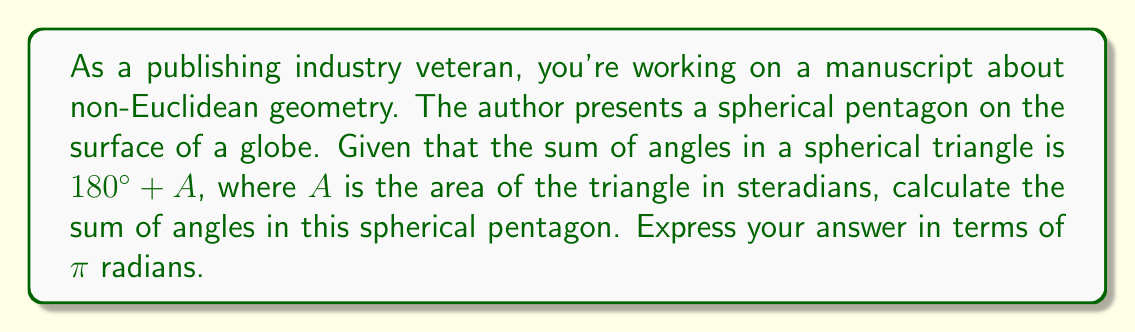Help me with this question. Let's approach this step-by-step:

1) First, recall that any spherical polygon can be divided into $(n-2)$ spherical triangles, where $n$ is the number of sides. For a pentagon, $n=5$, so we can divide it into 3 spherical triangles.

2) The sum of angles in a spherical triangle is given by:
   $$S_{triangle} = \pi + A$$
   where $A$ is the area of the triangle in steradians.

3) For our pentagon, the sum of angles will be the sum of the angles in these 3 triangles:
   $$S_{pentagon} = 3(\pi + A_1 + A_2 + A_3)$$
   where $A_1$, $A_2$, and $A_3$ are the areas of the three triangles.

4) The sum $A_1 + A_2 + A_3$ is simply the area of the entire pentagon. Let's call this $A_{pentagon}$.

5) Therefore, we can write:
   $$S_{pentagon} = 3\pi + A_{pentagon}$$

6) Now, we need to consider the area of a sphere. The total area of a sphere is $4\pi$ steradians.

7) A pentagon can cover at most half of a sphere's surface (if it were larger, it would no longer be a pentagon but would wrap around to form a different shape).

8) Therefore, $0 < A_{pentagon} \leq 2\pi$

9) Substituting this back into our equation:
   $$3\pi < S_{pentagon} \leq 5\pi$$

10) Thus, the sum of angles in a spherical pentagon is always greater than $3\pi$ radians and at most $5\pi$ radians.
Answer: $3\pi < S_{pentagon} \leq 5\pi$ radians 